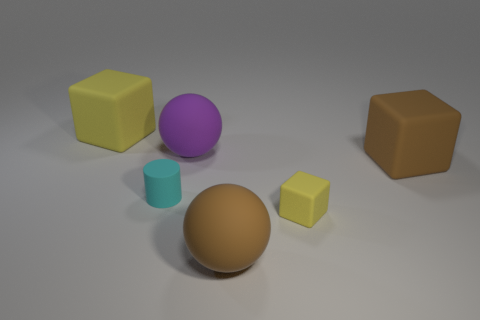What size is the other yellow matte object that is the same shape as the tiny yellow thing?
Offer a very short reply. Large. What number of objects are either yellow blocks that are right of the tiny cyan matte object or matte blocks that are behind the tiny cyan cylinder?
Your response must be concise. 3. Does the purple rubber thing have the same size as the brown matte block?
Give a very brief answer. Yes. Are there more balls than blue metallic cubes?
Provide a succinct answer. Yes. How many other things are there of the same color as the small rubber cylinder?
Keep it short and to the point. 0. What number of objects are small cyan rubber objects or matte balls?
Make the answer very short. 3. Do the large matte thing that is in front of the small cube and the big purple matte thing have the same shape?
Your answer should be compact. Yes. What color is the big rubber cube that is in front of the yellow cube that is to the left of the big brown sphere?
Make the answer very short. Brown. Are there fewer big yellow objects than yellow matte things?
Give a very brief answer. Yes. Is there a brown ball that has the same material as the small cyan cylinder?
Offer a very short reply. Yes. 